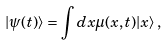Convert formula to latex. <formula><loc_0><loc_0><loc_500><loc_500>| \psi ( t ) \rangle = \int d x \mu ( x , t ) | x \rangle \, ,</formula> 